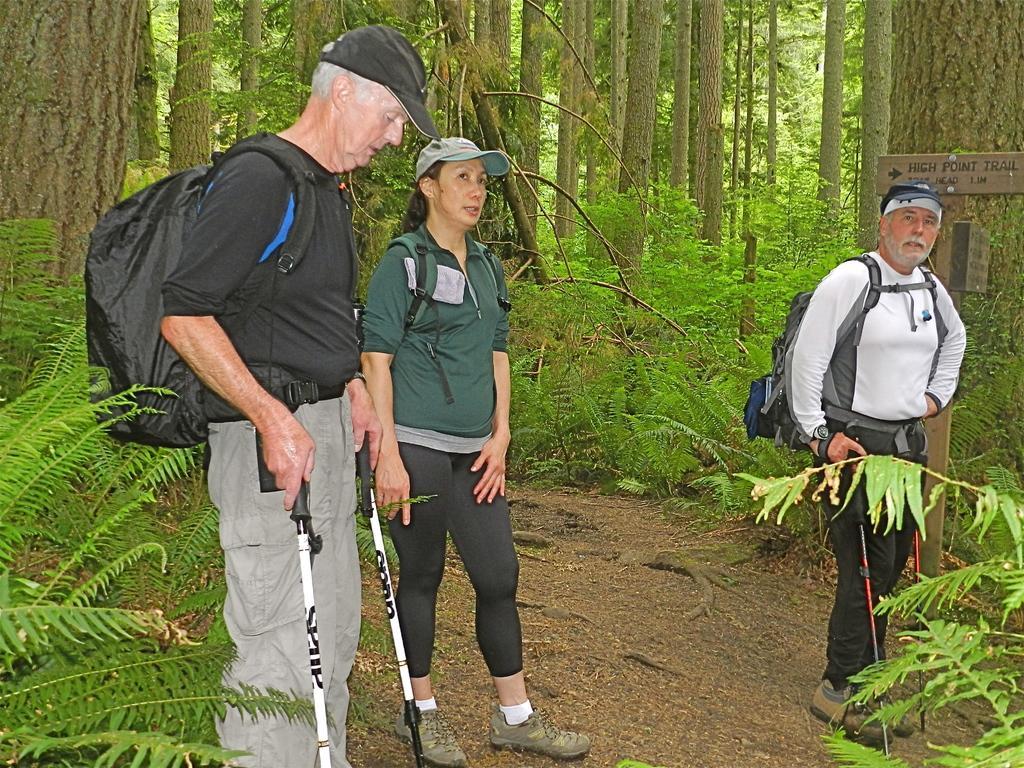Could you give a brief overview of what you see in this image? There are three persons standing in the middle of this image. The person standing on the right side is wearing a white color t shirt and holding a stick and wearing a backpack. The person standing in the middle is also wearing a backpack and a cap. The person standing on the left side is wearing a black color t shirt and a black color cap and a backpack. There are some trees in the background. 